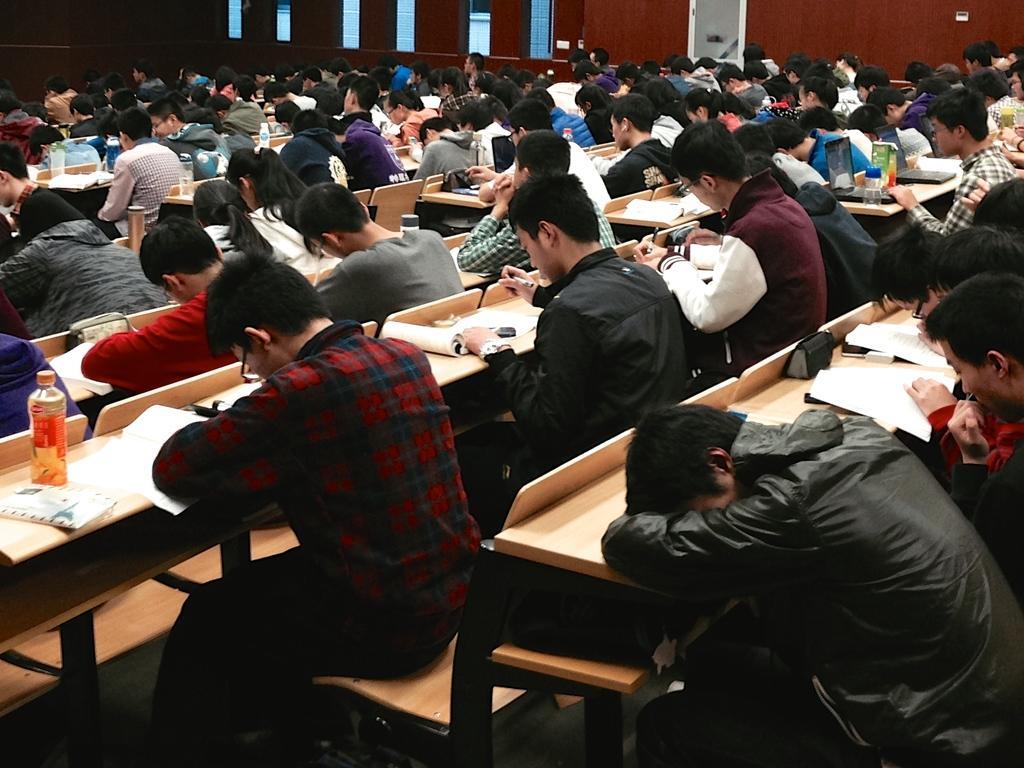Could you give a brief overview of what you see in this image? This is a picture in a seminar room. There are group of people sitting on the table in front of them there is other table on the table there is a books and bottle and laptop also. Background of them is a red wall and windows. 